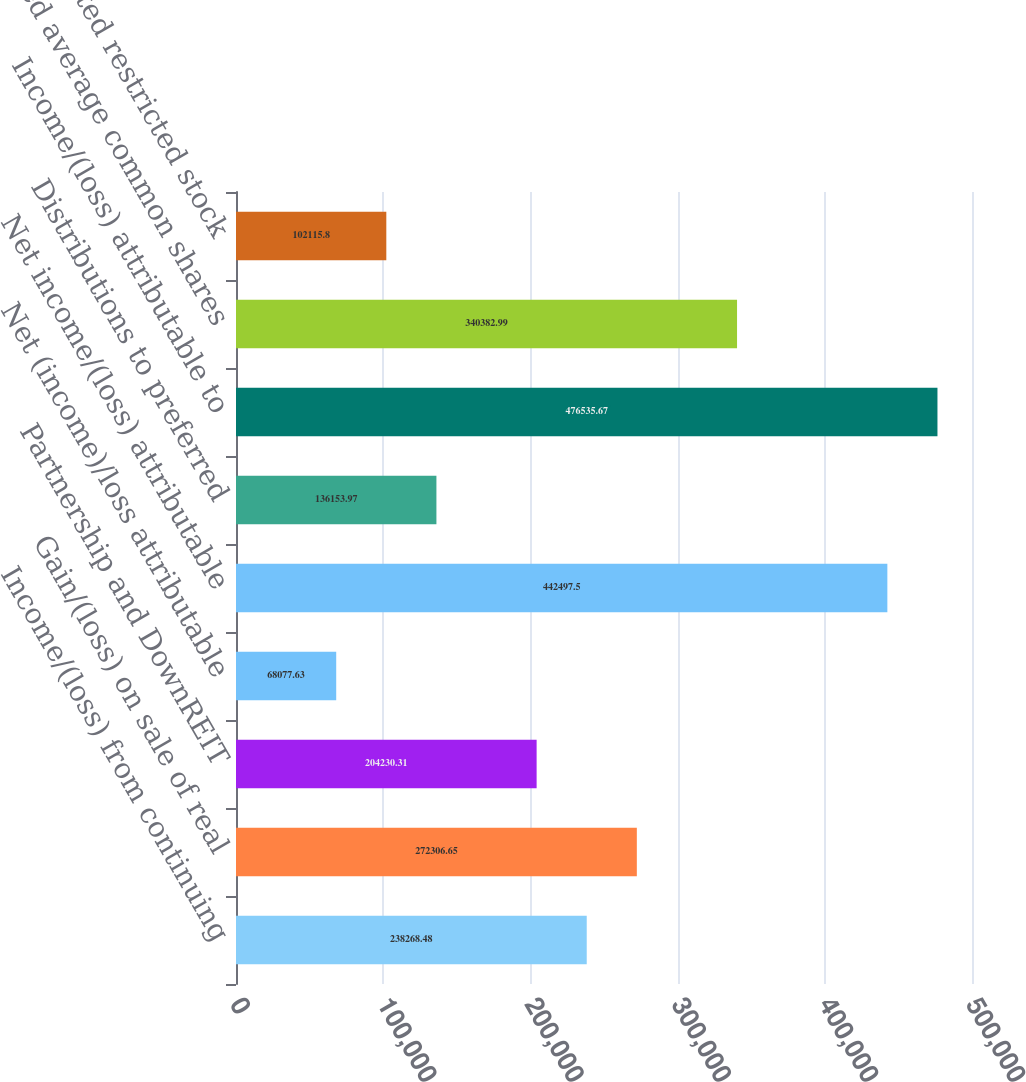Convert chart to OTSL. <chart><loc_0><loc_0><loc_500><loc_500><bar_chart><fcel>Income/(loss) from continuing<fcel>Gain/(loss) on sale of real<fcel>Partnership and DownREIT<fcel>Net (income)/loss attributable<fcel>Net income/(loss) attributable<fcel>Distributions to preferred<fcel>Income/(loss) attributable to<fcel>Weighted average common shares<fcel>Non-vested restricted stock<nl><fcel>238268<fcel>272307<fcel>204230<fcel>68077.6<fcel>442498<fcel>136154<fcel>476536<fcel>340383<fcel>102116<nl></chart> 